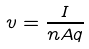<formula> <loc_0><loc_0><loc_500><loc_500>v = \frac { I } { n A q }</formula> 